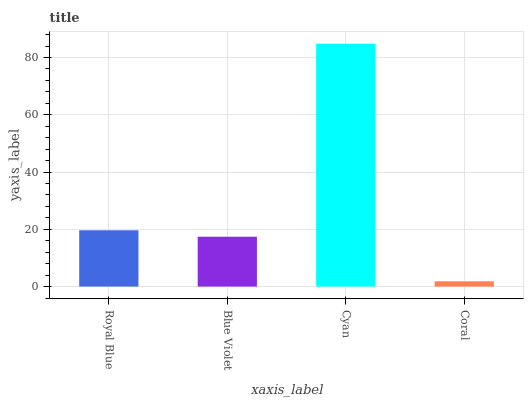Is Coral the minimum?
Answer yes or no. Yes. Is Cyan the maximum?
Answer yes or no. Yes. Is Blue Violet the minimum?
Answer yes or no. No. Is Blue Violet the maximum?
Answer yes or no. No. Is Royal Blue greater than Blue Violet?
Answer yes or no. Yes. Is Blue Violet less than Royal Blue?
Answer yes or no. Yes. Is Blue Violet greater than Royal Blue?
Answer yes or no. No. Is Royal Blue less than Blue Violet?
Answer yes or no. No. Is Royal Blue the high median?
Answer yes or no. Yes. Is Blue Violet the low median?
Answer yes or no. Yes. Is Cyan the high median?
Answer yes or no. No. Is Cyan the low median?
Answer yes or no. No. 